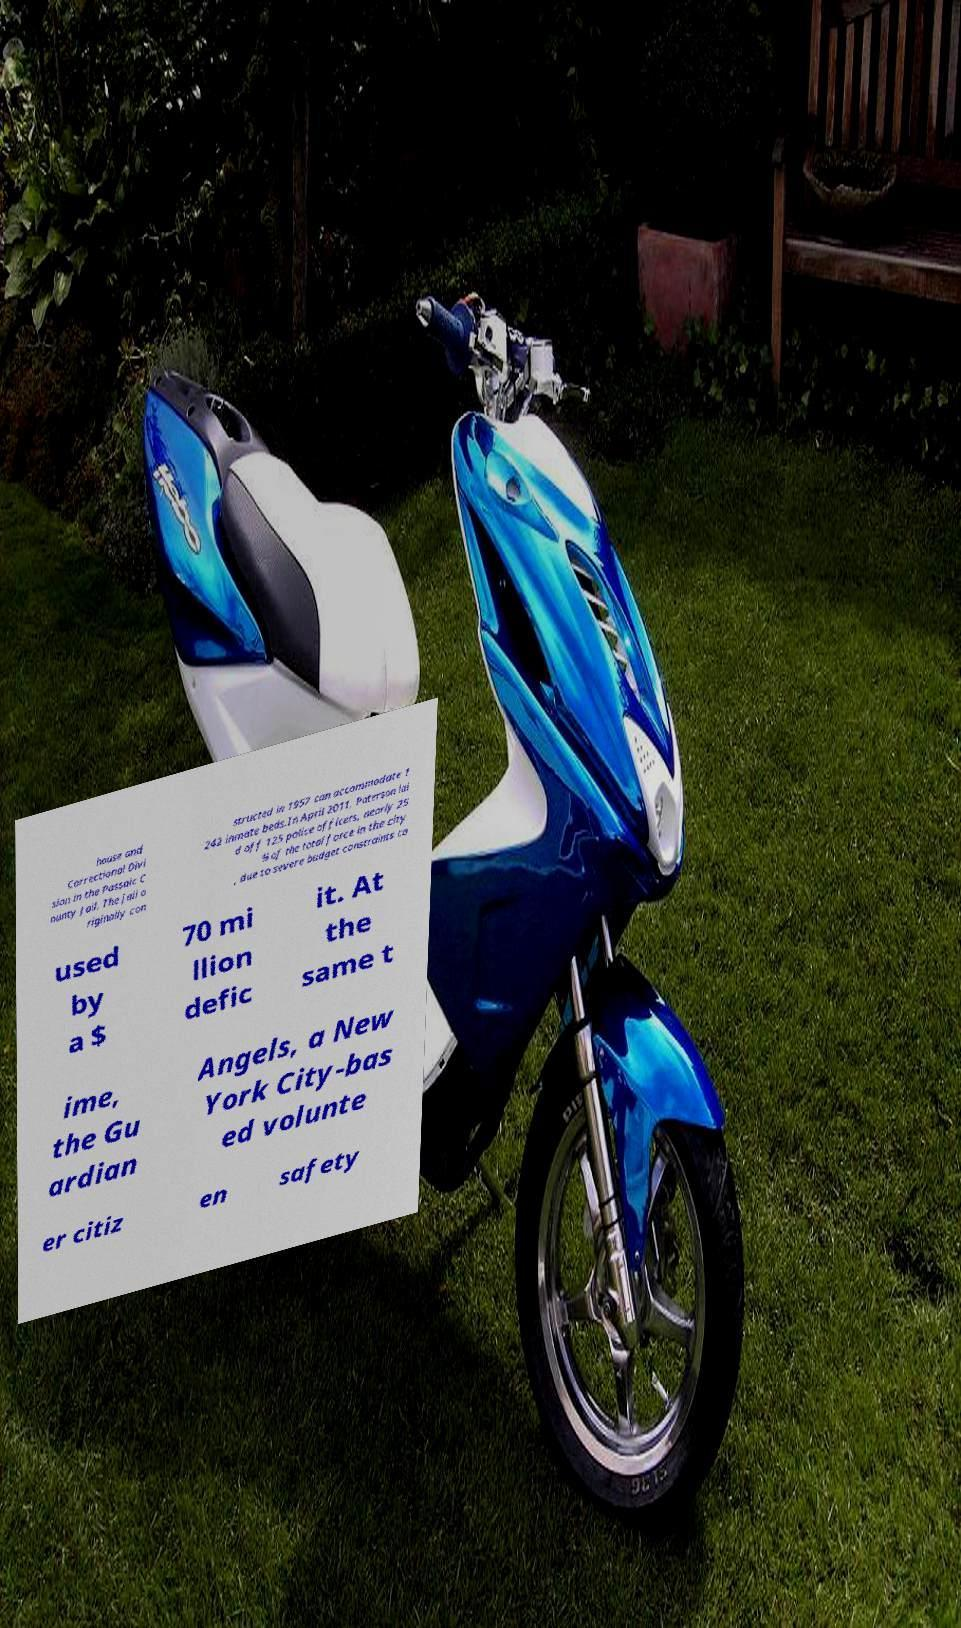What messages or text are displayed in this image? I need them in a readable, typed format. house and Correctional Divi sion in the Passaic C ounty Jail. The jail o riginally con structed in 1957 can accommodate 1 242 inmate beds.In April 2011, Paterson lai d off 125 police officers, nearly 25 % of the total force in the city , due to severe budget constraints ca used by a $ 70 mi llion defic it. At the same t ime, the Gu ardian Angels, a New York City-bas ed volunte er citiz en safety 